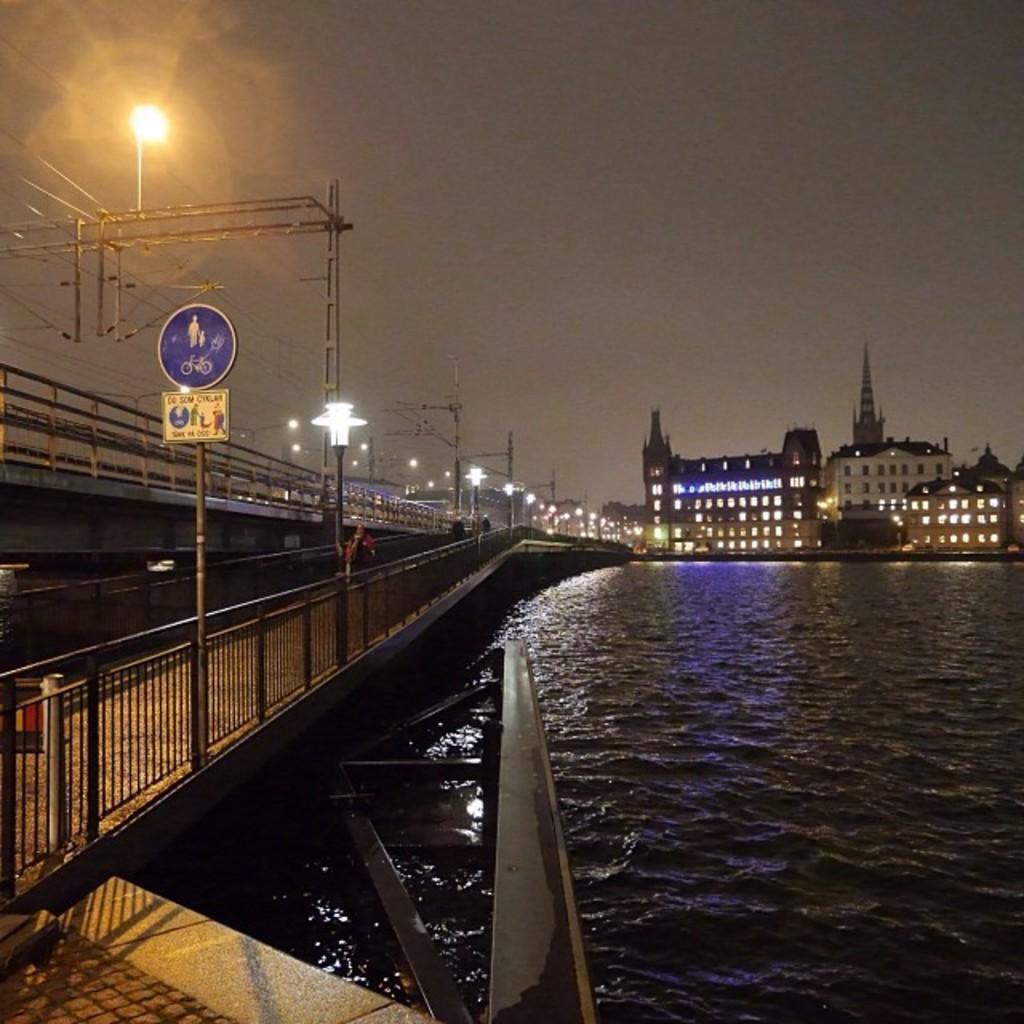Can you describe this image briefly? In this image we can see water, bridge, persons, buildings, lights, poles and sky. 